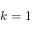Convert formula to latex. <formula><loc_0><loc_0><loc_500><loc_500>k = 1</formula> 